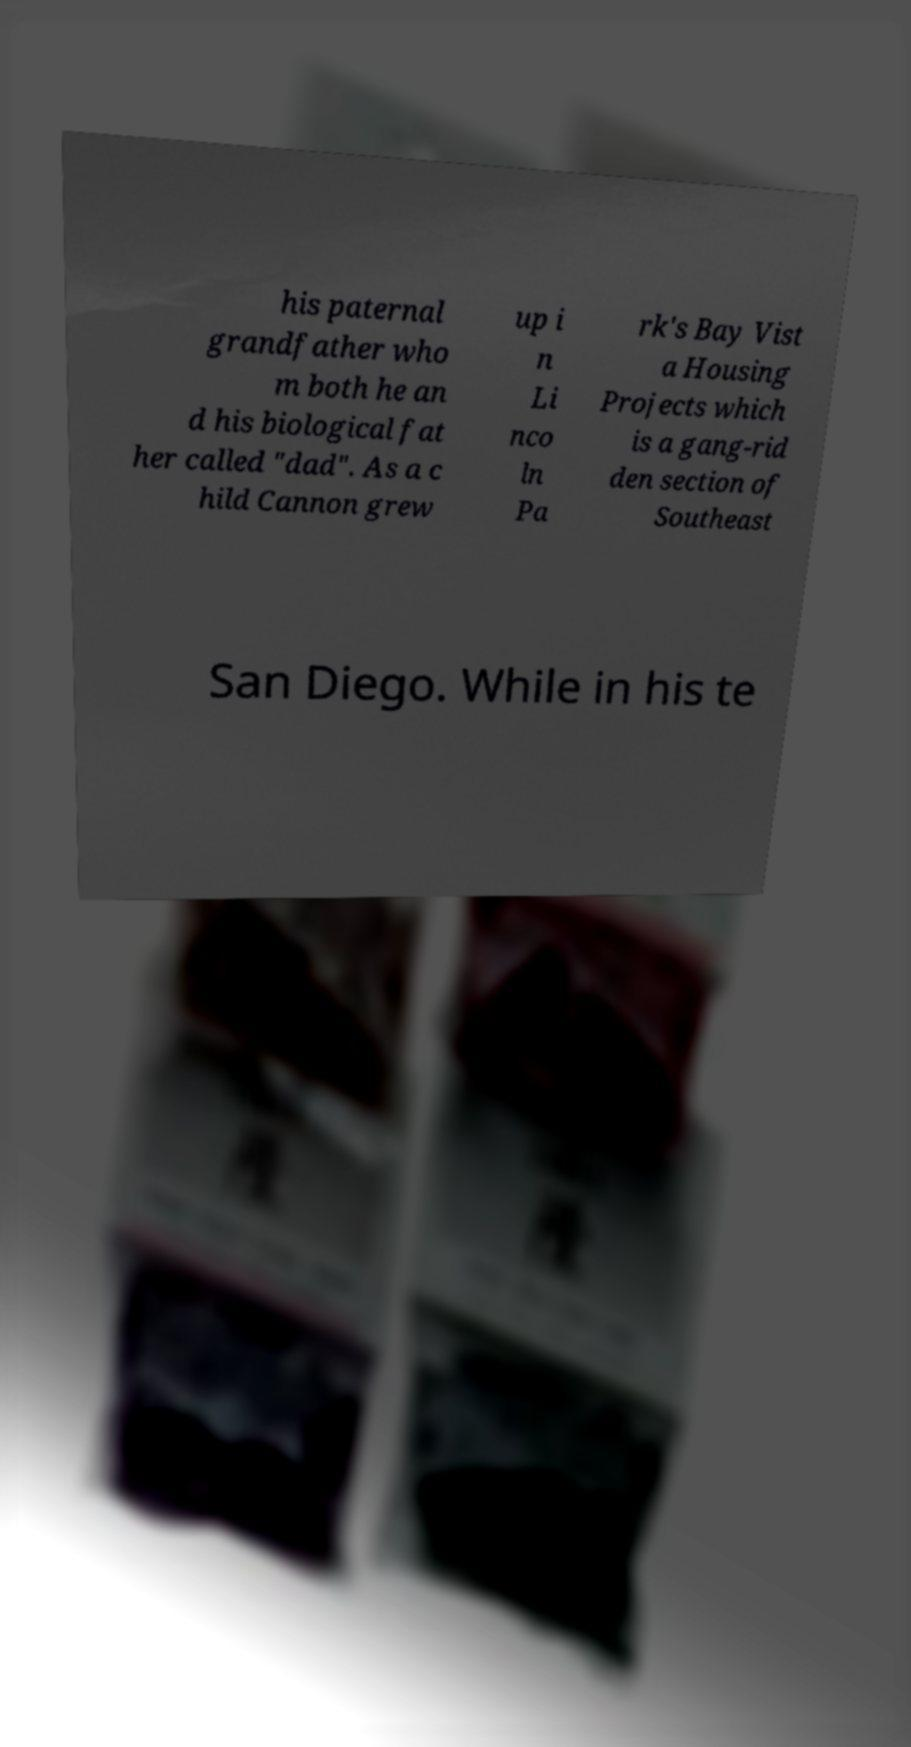Please read and relay the text visible in this image. What does it say? his paternal grandfather who m both he an d his biological fat her called "dad". As a c hild Cannon grew up i n Li nco ln Pa rk's Bay Vist a Housing Projects which is a gang-rid den section of Southeast San Diego. While in his te 